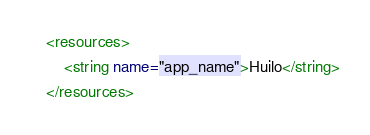<code> <loc_0><loc_0><loc_500><loc_500><_XML_><resources>
    <string name="app_name">Huilo</string>
</resources>
</code> 